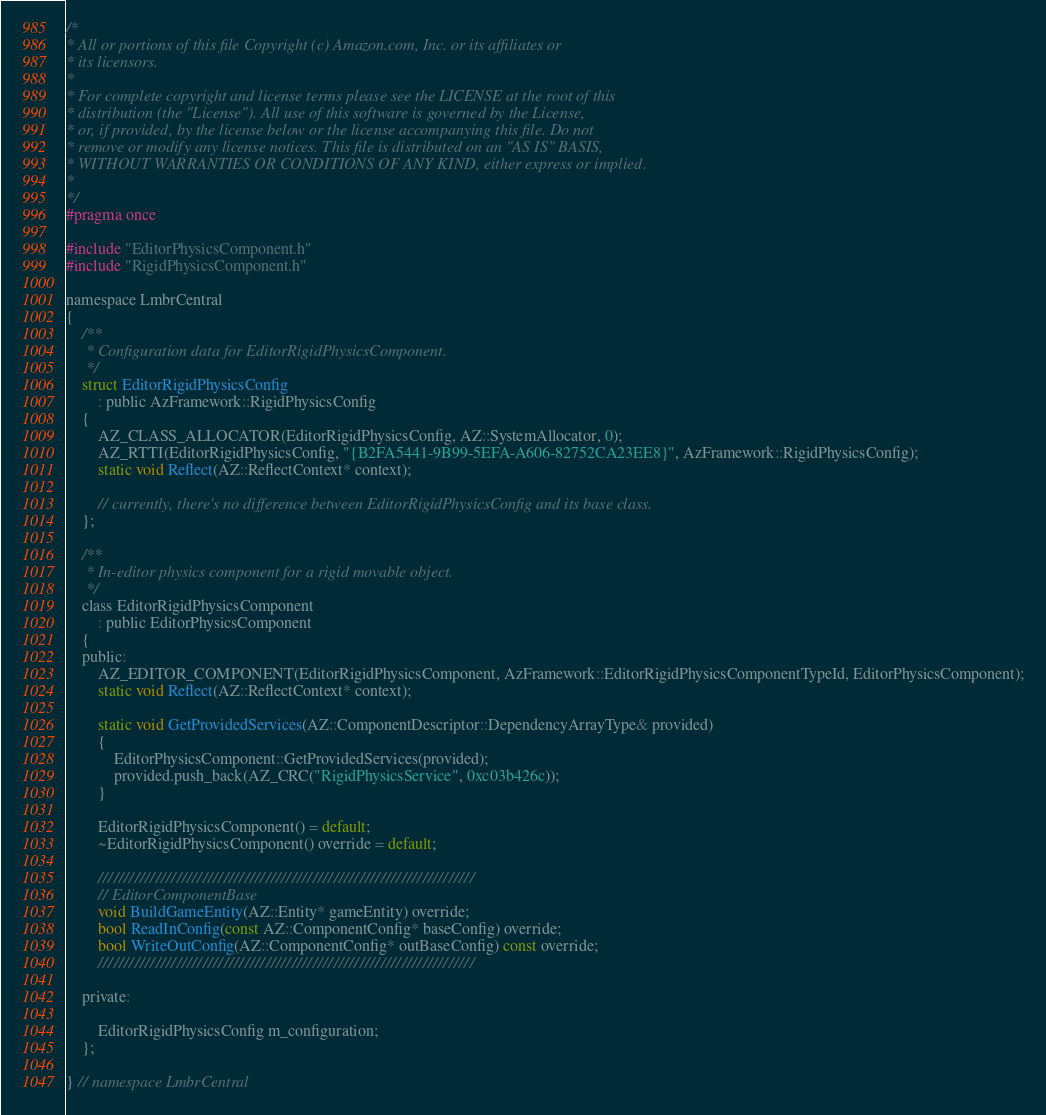<code> <loc_0><loc_0><loc_500><loc_500><_C_>/*
* All or portions of this file Copyright (c) Amazon.com, Inc. or its affiliates or
* its licensors.
*
* For complete copyright and license terms please see the LICENSE at the root of this
* distribution (the "License"). All use of this software is governed by the License,
* or, if provided, by the license below or the license accompanying this file. Do not
* remove or modify any license notices. This file is distributed on an "AS IS" BASIS,
* WITHOUT WARRANTIES OR CONDITIONS OF ANY KIND, either express or implied.
*
*/
#pragma once

#include "EditorPhysicsComponent.h"
#include "RigidPhysicsComponent.h"

namespace LmbrCentral
{
    /**
     * Configuration data for EditorRigidPhysicsComponent.
     */
    struct EditorRigidPhysicsConfig
        : public AzFramework::RigidPhysicsConfig
    {
        AZ_CLASS_ALLOCATOR(EditorRigidPhysicsConfig, AZ::SystemAllocator, 0);
        AZ_RTTI(EditorRigidPhysicsConfig, "{B2FA5441-9B99-5EFA-A606-82752CA23EE8}", AzFramework::RigidPhysicsConfig);
        static void Reflect(AZ::ReflectContext* context);

        // currently, there's no difference between EditorRigidPhysicsConfig and its base class.
    };

    /**
     * In-editor physics component for a rigid movable object.
     */
    class EditorRigidPhysicsComponent
        : public EditorPhysicsComponent
    {
    public:
        AZ_EDITOR_COMPONENT(EditorRigidPhysicsComponent, AzFramework::EditorRigidPhysicsComponentTypeId, EditorPhysicsComponent);
        static void Reflect(AZ::ReflectContext* context);

        static void GetProvidedServices(AZ::ComponentDescriptor::DependencyArrayType& provided)
        {
            EditorPhysicsComponent::GetProvidedServices(provided);
            provided.push_back(AZ_CRC("RigidPhysicsService", 0xc03b426c));
        }

        EditorRigidPhysicsComponent() = default;
        ~EditorRigidPhysicsComponent() override = default;

        ////////////////////////////////////////////////////////////////////////
        // EditorComponentBase
        void BuildGameEntity(AZ::Entity* gameEntity) override;
        bool ReadInConfig(const AZ::ComponentConfig* baseConfig) override;
        bool WriteOutConfig(AZ::ComponentConfig* outBaseConfig) const override;
        ////////////////////////////////////////////////////////////////////////

    private:

        EditorRigidPhysicsConfig m_configuration;
    };

} // namespace LmbrCentral</code> 